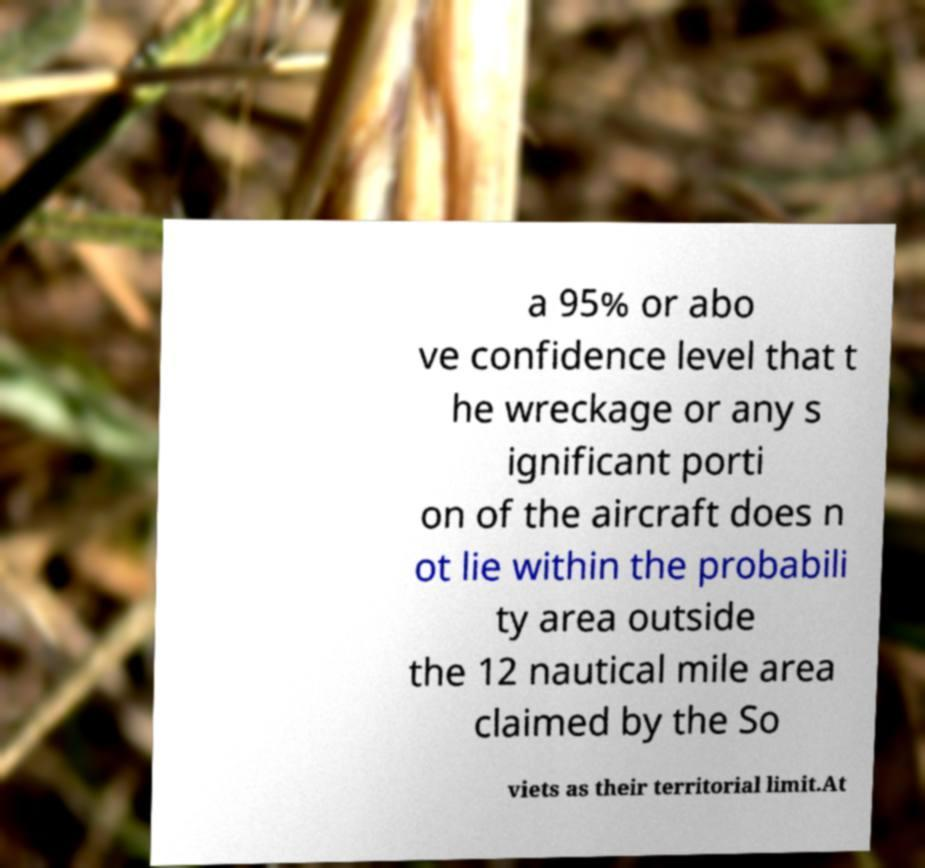For documentation purposes, I need the text within this image transcribed. Could you provide that? a 95% or abo ve confidence level that t he wreckage or any s ignificant porti on of the aircraft does n ot lie within the probabili ty area outside the 12 nautical mile area claimed by the So viets as their territorial limit.At 